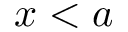Convert formula to latex. <formula><loc_0><loc_0><loc_500><loc_500>x < a</formula> 